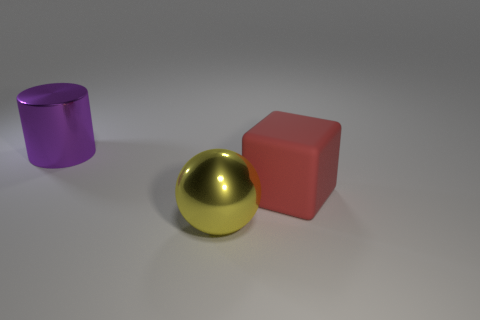Add 3 big shiny cubes. How many objects exist? 6 Subtract all cubes. How many objects are left? 2 Add 1 large red matte objects. How many large red matte objects exist? 2 Subtract 0 purple cubes. How many objects are left? 3 Subtract all big cubes. Subtract all big purple objects. How many objects are left? 1 Add 1 big cubes. How many big cubes are left? 2 